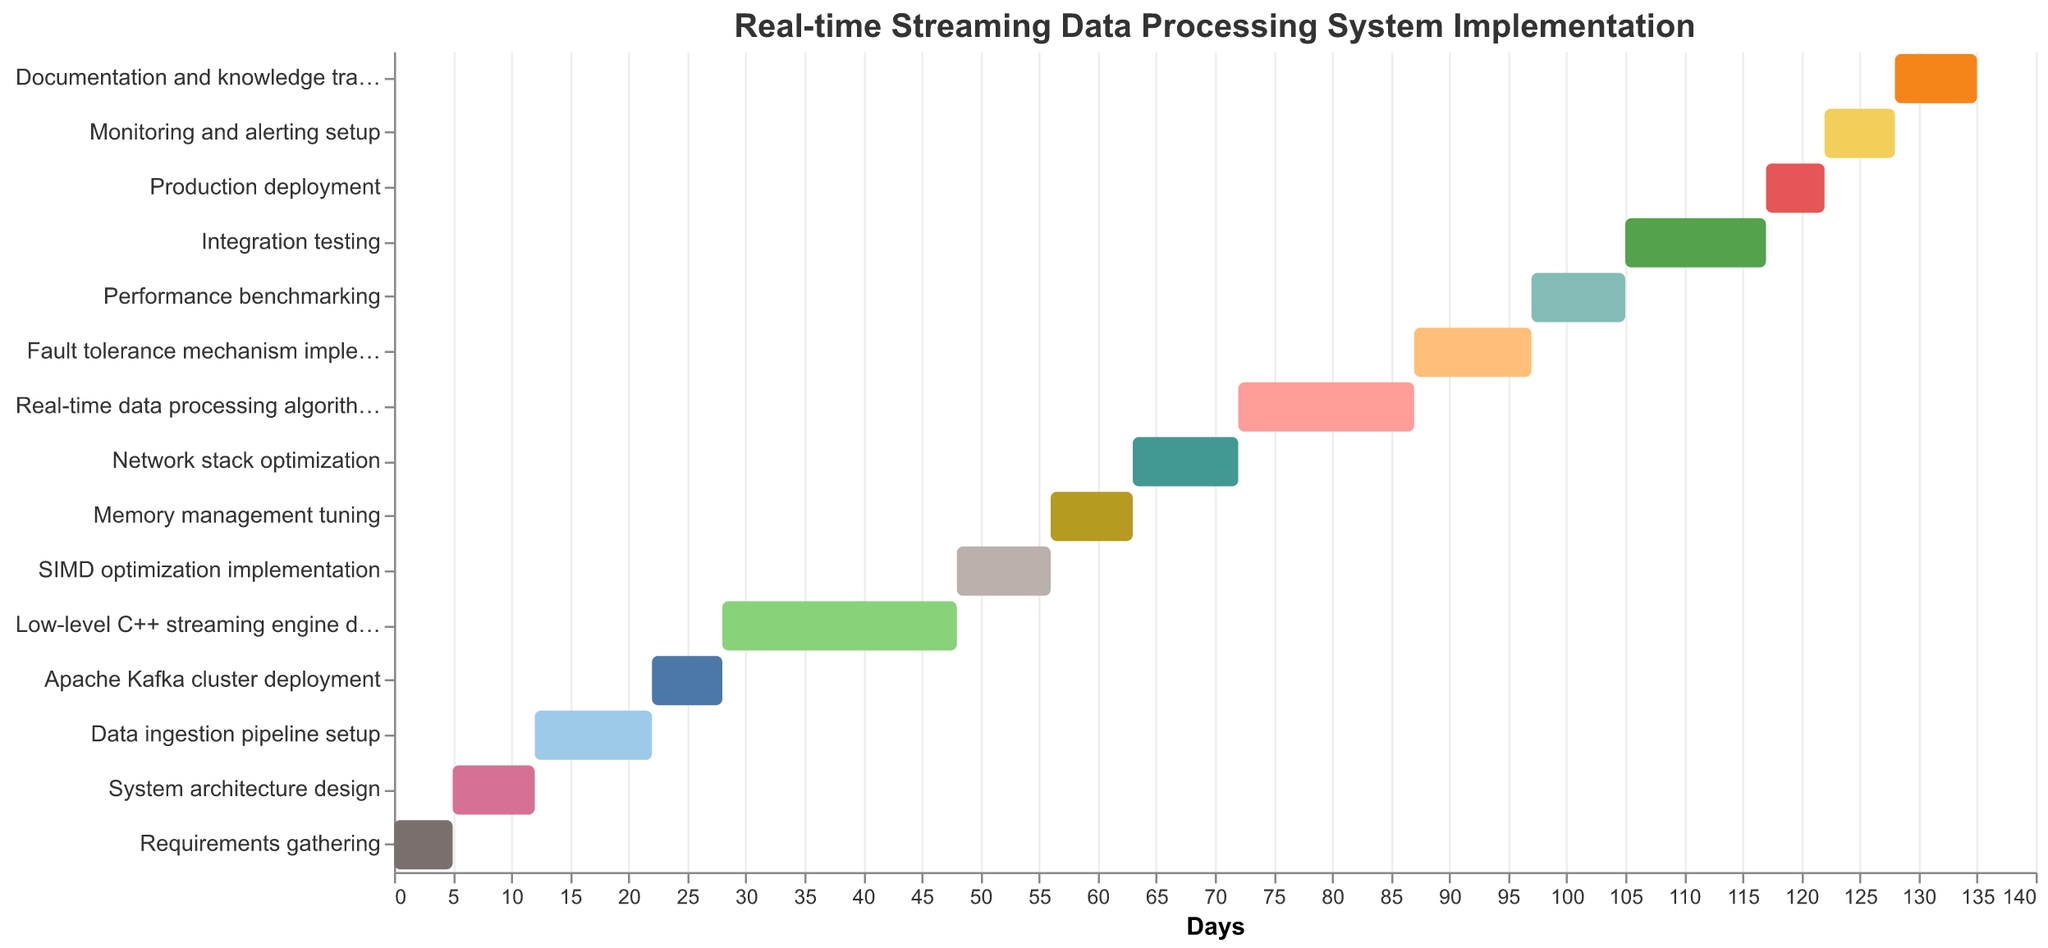What is the title of the figure? The title is displayed at the top of the figure. It is "Real-time Streaming Data Processing System Implementation".
Answer: Real-time Streaming Data Processing System Implementation Which task takes the longest duration to complete and how many days does it take? Examine the duration of each task shown in the figure. The task with the longest duration is "Low-level C++ streaming engine development" with a duration of 20 days.
Answer: Low-level C++ streaming engine development, 20 days When does the "Data ingestion pipeline setup" task start and end? The "Data ingestion pipeline setup" task is shown to start at day 12 and, since its duration is 10 days, it ends at day 22.
Answer: Starts at day 12 and ends at day 22 Which task follows immediately after the completion of "SIMD optimization implementation"? "SIMD optimization implementation" ends at day 56 (start at 48, duration of 8 days). The next task that starts at day 56 is "Memory management tuning".
Answer: Memory management tuning How long does the phase that includes "Apache Kafka cluster deployment" to "Network stack optimization" last in total? The "Apache Kafka cluster deployment" starts at day 22 and lasts 6 days (ending at day 28). The "Network stack optimization" starts at day 63 and lasts 9 days (ends day 72). Therefore, consider the period from the start of "Apache Kafka cluster deployment" to the end of "Network stack optimization". This is day 22 to day 72, which is 50 days in total.
Answer: 50 days What is the duration difference between "Integration testing" and "Production deployment"? "Integration testing" has a duration of 12 days (starts at day 105) and "Production deployment" has a duration of 5 days (starts at day 117). The duration difference is 12 - 5 = 7 days.
Answer: 7 days Which tasks overlap with the "Real-time data processing algorithms" task? The "Real-time data processing algorithms" task starts at day 72 and lasts for 15 days (ends at day 87). This period overlaps with "Network stack optimization" (which ends at day 72), "Fault tolerance mechanism implementation" (starts at day 87, exactly when the other task ends), so it doesn't overlap with any task.
Answer: None What percentage of the total implementation time is dedicated to "Fault tolerance mechanism implementation"? The total implementation time spans from day 0 to day 135 (the end of "Documentation and knowledge transfer"), which is 135 days. The "Fault tolerance mechanism implementation" lasts for 10 days. The percentage is calculated as (10/135) * 100 ≈ 7.41%.
Answer: 7.41% How many days are allocated for the "Benchmarking and testing" phases combined? Benchmarking is covered by "Performance benchmarking" (8 days) and testing by "Integration testing" (12 days). The combined duration is 8 + 12 = 20 days.
Answer: 20 days 